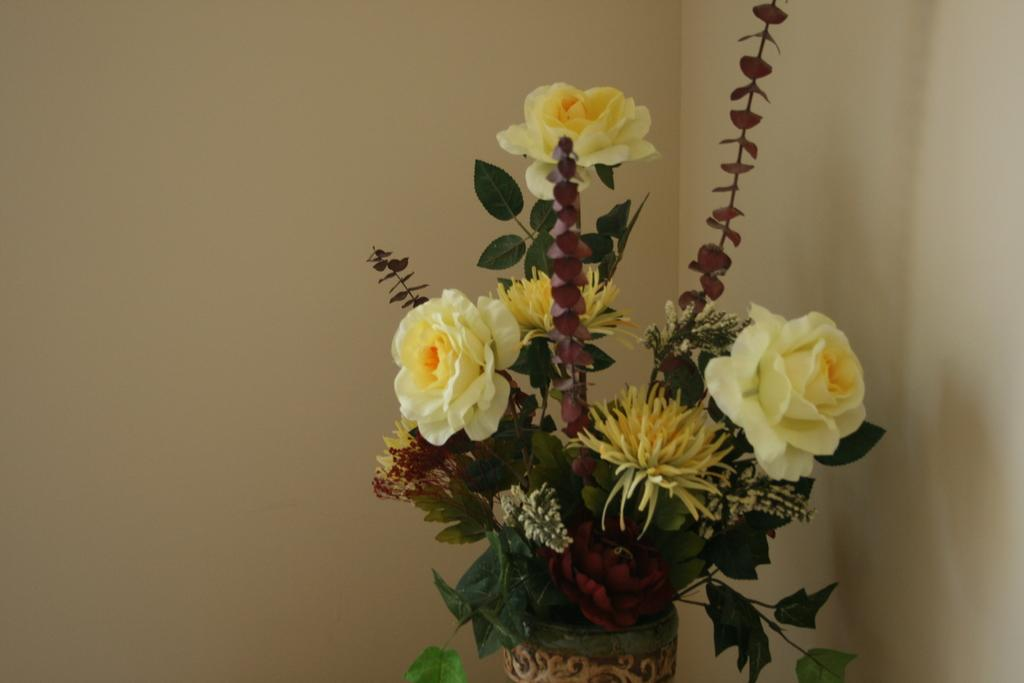What object is present in the image that contains flowers or leaves? There is a flower pot in the image that contains flowers or leaves. What can be seen behind the flower pot in the image? There is a wall visible behind the flower pot. What type of bottle is placed on the edge of the flower pot in the image? There is: There is no bottle present on the edge of the flower pot in the image. 